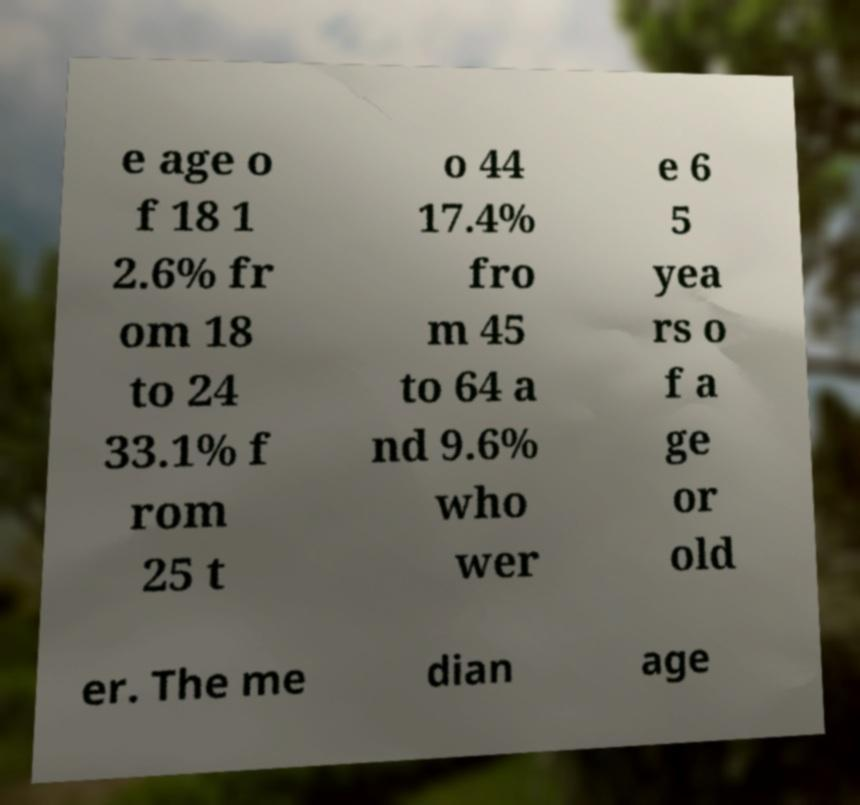Could you assist in decoding the text presented in this image and type it out clearly? e age o f 18 1 2.6% fr om 18 to 24 33.1% f rom 25 t o 44 17.4% fro m 45 to 64 a nd 9.6% who wer e 6 5 yea rs o f a ge or old er. The me dian age 